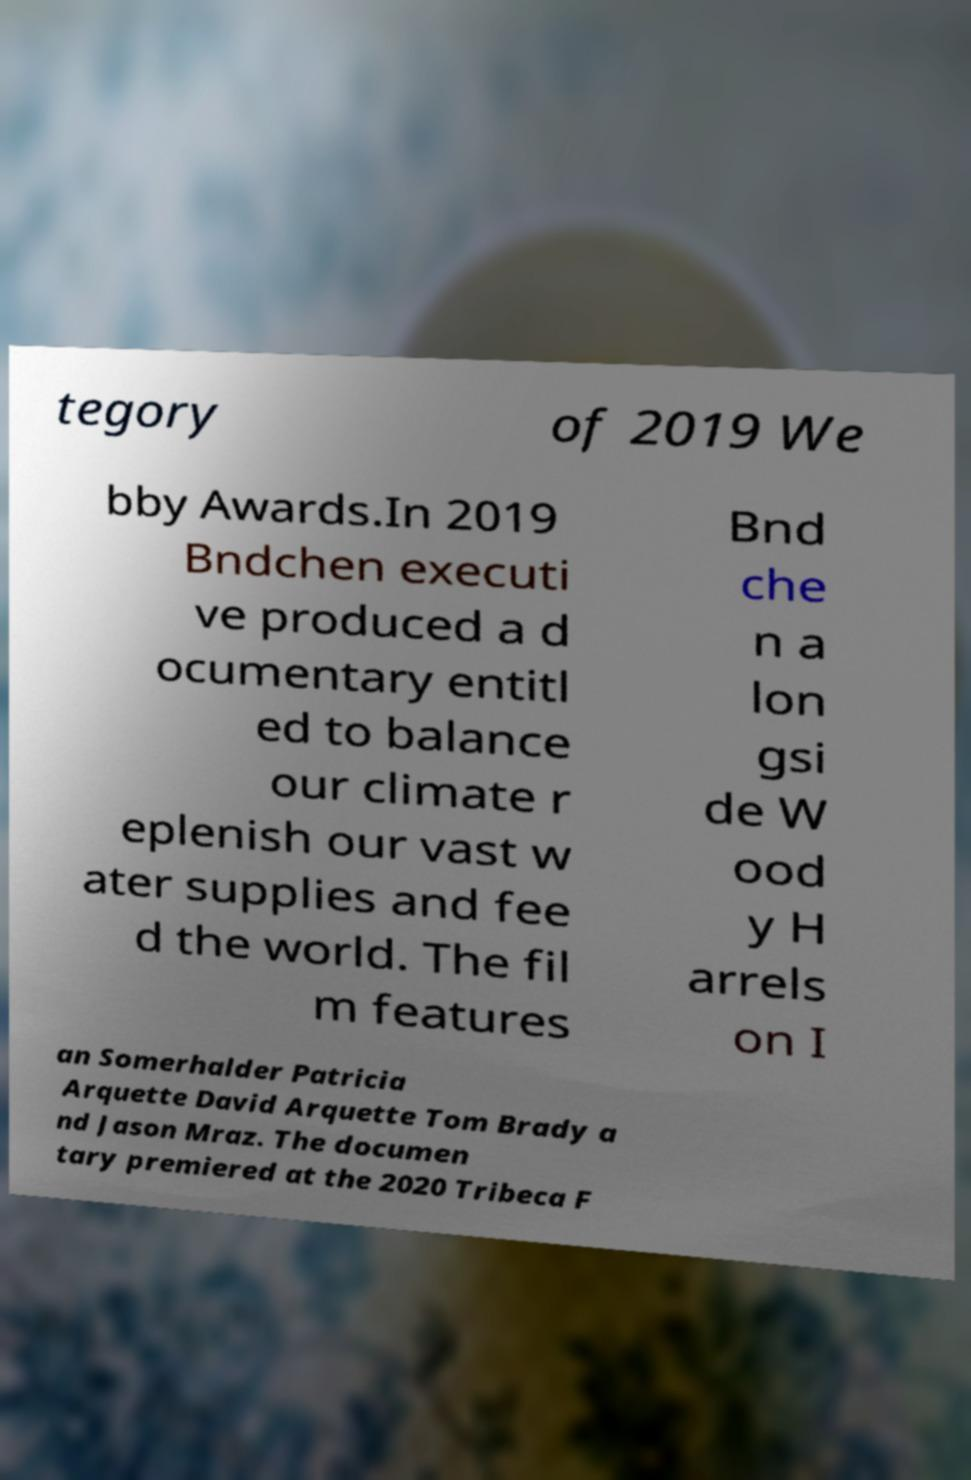Can you read and provide the text displayed in the image?This photo seems to have some interesting text. Can you extract and type it out for me? tegory of 2019 We bby Awards.In 2019 Bndchen executi ve produced a d ocumentary entitl ed to balance our climate r eplenish our vast w ater supplies and fee d the world. The fil m features Bnd che n a lon gsi de W ood y H arrels on I an Somerhalder Patricia Arquette David Arquette Tom Brady a nd Jason Mraz. The documen tary premiered at the 2020 Tribeca F 